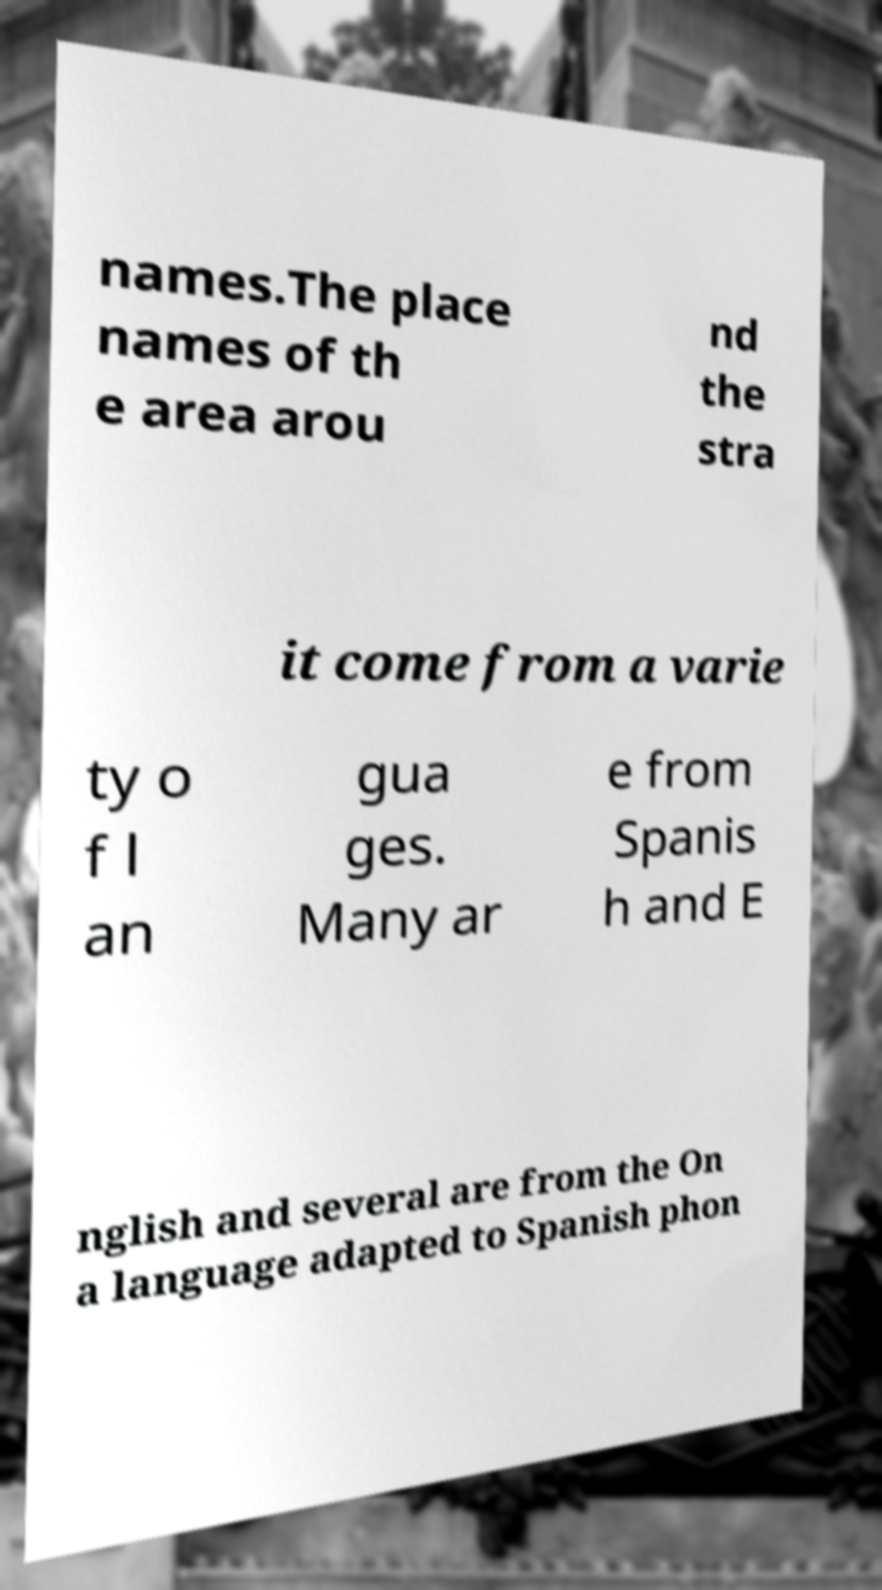Can you read and provide the text displayed in the image?This photo seems to have some interesting text. Can you extract and type it out for me? names.The place names of th e area arou nd the stra it come from a varie ty o f l an gua ges. Many ar e from Spanis h and E nglish and several are from the On a language adapted to Spanish phon 